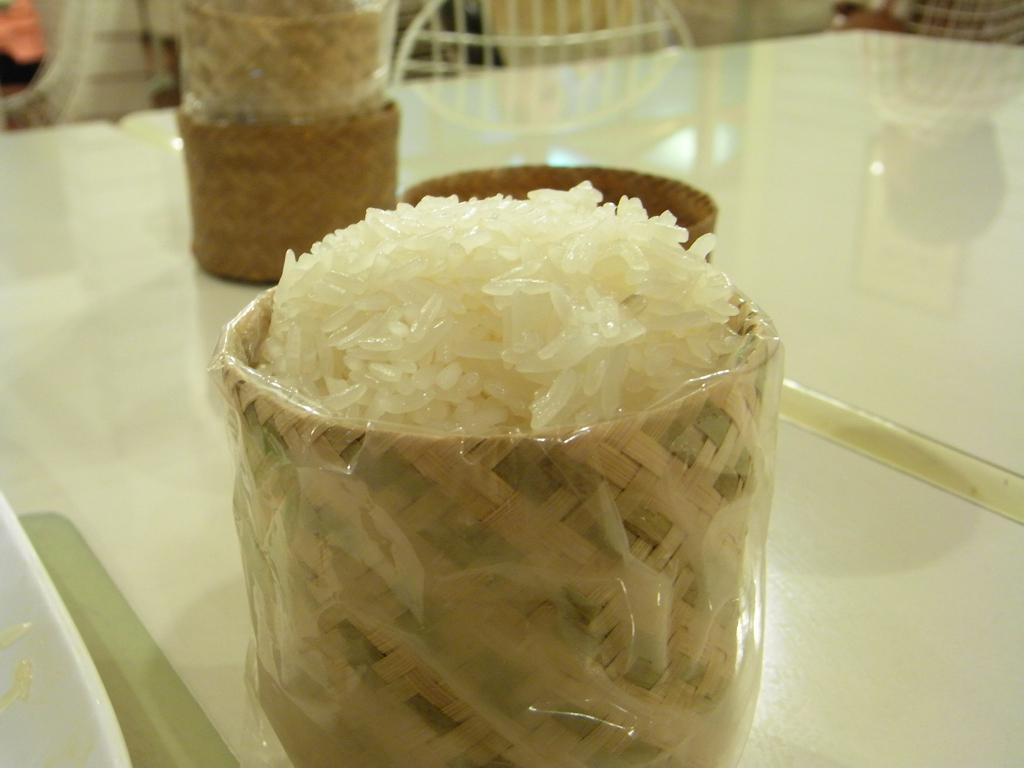Describe this image in one or two sentences. In this image we can see bowls containing rice wrapped in the polythene covers and are placed on the table. 